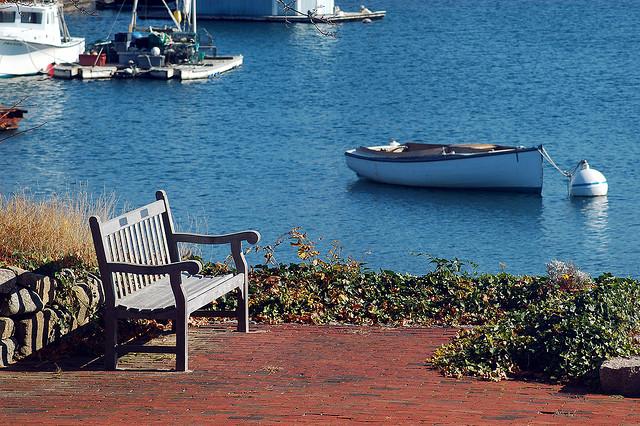What is tied to the boat?
Keep it brief. Buoy. What level of class-status would this picture be associated with?
Concise answer only. High. How many people are on the bench?
Keep it brief. 0. 